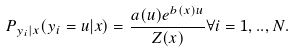<formula> <loc_0><loc_0><loc_500><loc_500>P _ { y _ { i } | x } ( y _ { i } = u | x ) = \frac { a ( u ) e ^ { b ( x ) u } } { Z ( x ) } \forall i = 1 , . . , N .</formula> 